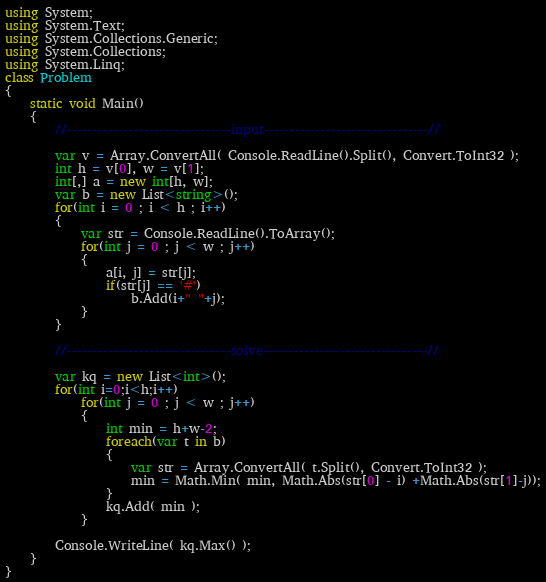<code> <loc_0><loc_0><loc_500><loc_500><_C#_>using System;
using System.Text;
using System.Collections.Generic;
using System.Collections;
using System.Linq;
class Problem
{
    static void Main()
    {
        //--------------------------------input--------------------------------//

        var v = Array.ConvertAll( Console.ReadLine().Split(), Convert.ToInt32 );
        int h = v[0], w = v[1];
        int[,] a = new int[h, w];
        var b = new List<string>();
        for(int i = 0 ; i < h ; i++)
        {
            var str = Console.ReadLine().ToArray();
            for(int j = 0 ; j < w ; j++)
            {
                a[i, j] = str[j];
                if(str[j] == '#')
                    b.Add(i+" "+j);
            }
        }

        //--------------------------------solve--------------------------------//

        var kq = new List<int>();
        for(int i=0;i<h;i++)
            for(int j = 0 ; j < w ; j++)
            {
                int min = h+w-2;
                foreach(var t in b)
                {
                    var str = Array.ConvertAll( t.Split(), Convert.ToInt32 );
                    min = Math.Min( min, Math.Abs(str[0] - i) +Math.Abs(str[1]-j));
                }
                kq.Add( min );
            }

        Console.WriteLine( kq.Max() );
    }
}</code> 